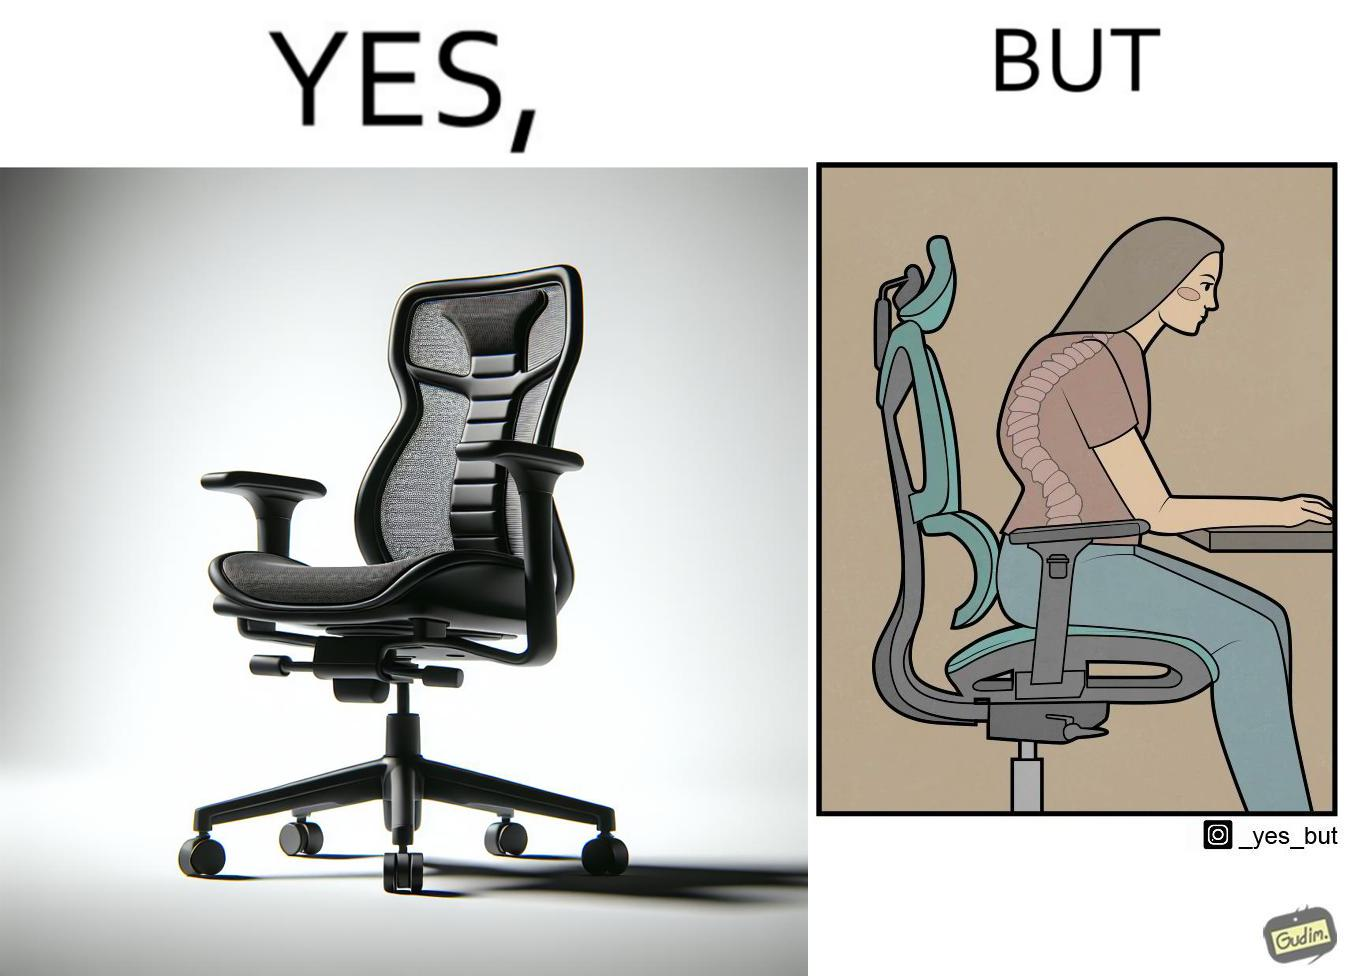Compare the left and right sides of this image. In the left part of the image: an ergonomic chair. In the right part of the image: a person sitting on a ergonomic chair with a bent spine. 